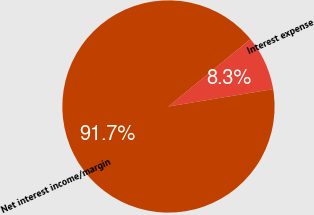Convert chart. <chart><loc_0><loc_0><loc_500><loc_500><pie_chart><fcel>Interest expense<fcel>Net interest income/margin<nl><fcel>8.33%<fcel>91.67%<nl></chart> 